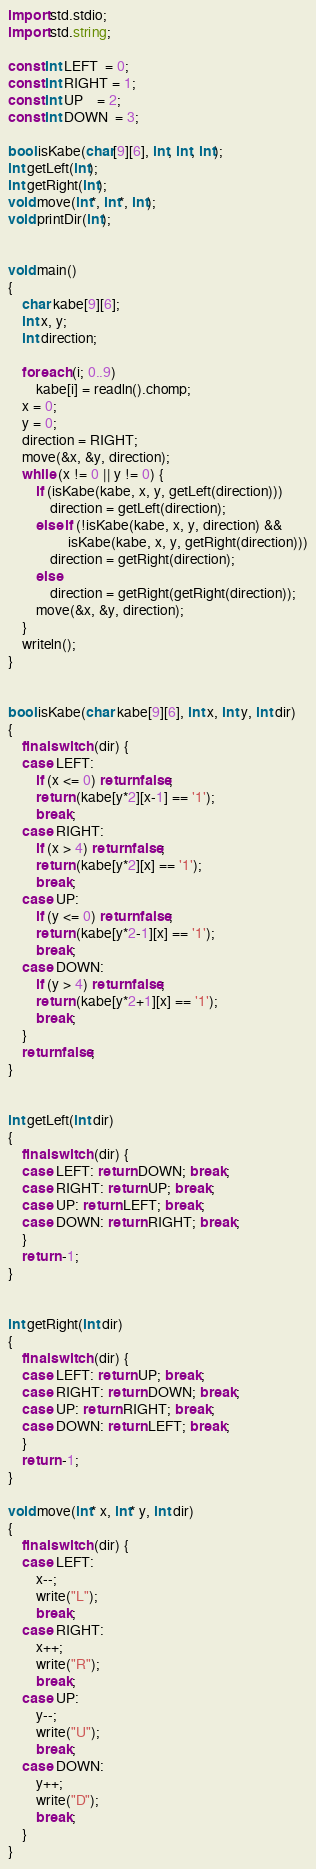<code> <loc_0><loc_0><loc_500><loc_500><_D_>import std.stdio;
import std.string;

const int LEFT  = 0;
const int RIGHT = 1;
const int UP    = 2;
const int DOWN  = 3;

bool isKabe(char[9][6], int, int, int);
int getLeft(int);
int getRight(int);
void move(int*, int*, int);
void printDir(int);


void main()
{
    char kabe[9][6];
    int x, y;
    int direction;

    foreach (i; 0..9)
        kabe[i] = readln().chomp;
    x = 0;
    y = 0;
    direction = RIGHT;
    move(&x, &y, direction);
    while (x != 0 || y != 0) {
        if (isKabe(kabe, x, y, getLeft(direction)))
            direction = getLeft(direction);
        else if (!isKabe(kabe, x, y, direction) &&
                 isKabe(kabe, x, y, getRight(direction)))
            direction = getRight(direction);
        else
            direction = getRight(getRight(direction));
        move(&x, &y, direction);
    }
    writeln();
}


bool isKabe(char kabe[9][6], int x, int y, int dir)
{
    final switch (dir) {
    case LEFT:
        if (x <= 0) return false;
        return (kabe[y*2][x-1] == '1');
        break;
    case RIGHT:
        if (x > 4) return false;
        return (kabe[y*2][x] == '1');
        break;
    case UP:
        if (y <= 0) return false;
        return (kabe[y*2-1][x] == '1');
        break;
    case DOWN:
        if (y > 4) return false;
        return (kabe[y*2+1][x] == '1');
        break;
    }
    return false;
}


int getLeft(int dir)
{
    final switch (dir) {
    case LEFT: return DOWN; break;
    case RIGHT: return UP; break;
    case UP: return LEFT; break;
    case DOWN: return RIGHT; break;
    }
    return -1;
}


int getRight(int dir)
{
    final switch (dir) {
    case LEFT: return UP; break;
    case RIGHT: return DOWN; break;
    case UP: return RIGHT; break;
    case DOWN: return LEFT; break;
    }
    return -1;
}

void move(int* x, int* y, int dir)
{
    final switch (dir) {
    case LEFT:
        x--;
        write("L");
        break;
    case RIGHT:
        x++;
        write("R");
        break;
    case UP:
        y--;
        write("U");
        break;
    case DOWN:
        y++;
        write("D");
        break;
    }
}</code> 